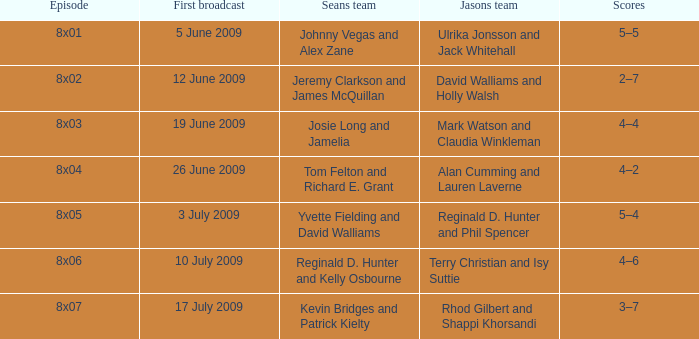Who was included in jason's team during the episode where sean's team had reginald d. hunter and kelly osbourne? Terry Christian and Isy Suttie. 